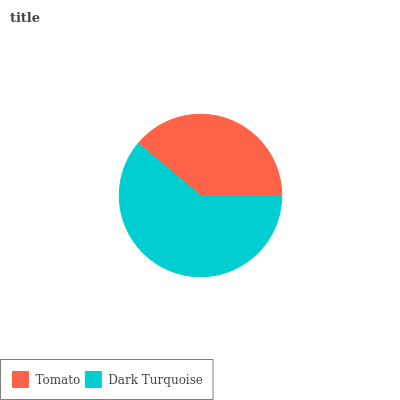Is Tomato the minimum?
Answer yes or no. Yes. Is Dark Turquoise the maximum?
Answer yes or no. Yes. Is Dark Turquoise the minimum?
Answer yes or no. No. Is Dark Turquoise greater than Tomato?
Answer yes or no. Yes. Is Tomato less than Dark Turquoise?
Answer yes or no. Yes. Is Tomato greater than Dark Turquoise?
Answer yes or no. No. Is Dark Turquoise less than Tomato?
Answer yes or no. No. Is Dark Turquoise the high median?
Answer yes or no. Yes. Is Tomato the low median?
Answer yes or no. Yes. Is Tomato the high median?
Answer yes or no. No. Is Dark Turquoise the low median?
Answer yes or no. No. 